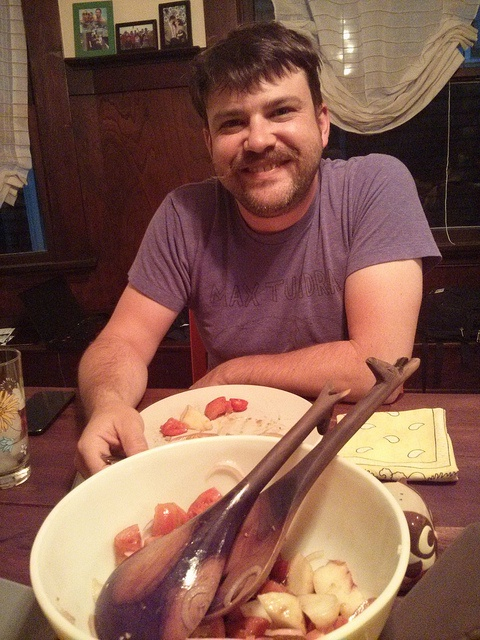Describe the objects in this image and their specific colors. I can see dining table in gray, tan, maroon, and brown tones, people in gray, maroon, brown, and salmon tones, bowl in gray, tan, brown, and maroon tones, spoon in gray, brown, maroon, and purple tones, and spoon in gray, maroon, and brown tones in this image. 